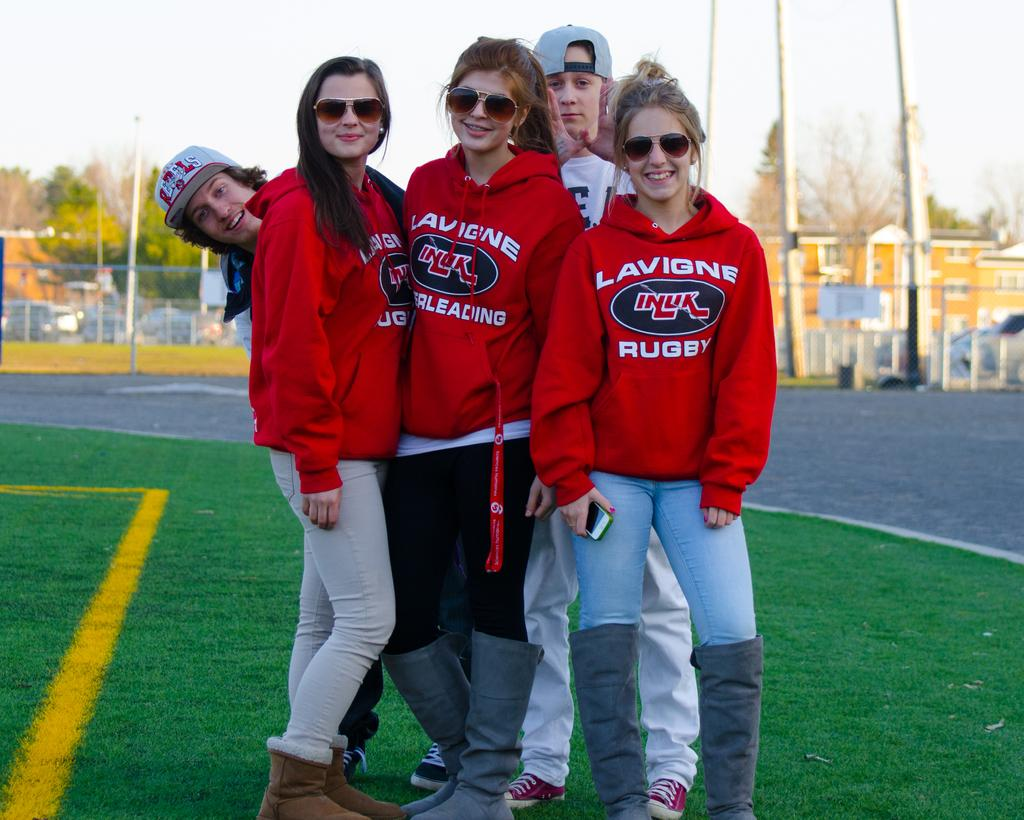<image>
Write a terse but informative summary of the picture. Red hoodies are being worn by three ladies to show their support for Lavigne Rugby. 